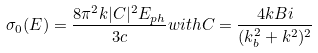Convert formula to latex. <formula><loc_0><loc_0><loc_500><loc_500>\sigma _ { 0 } ( E ) = \frac { 8 \pi ^ { 2 } k | C | ^ { 2 } E _ { p h } } { 3 c } w i t h C = \frac { 4 k B i } { ( k _ { b } ^ { 2 } + k ^ { 2 } ) ^ { 2 } }</formula> 